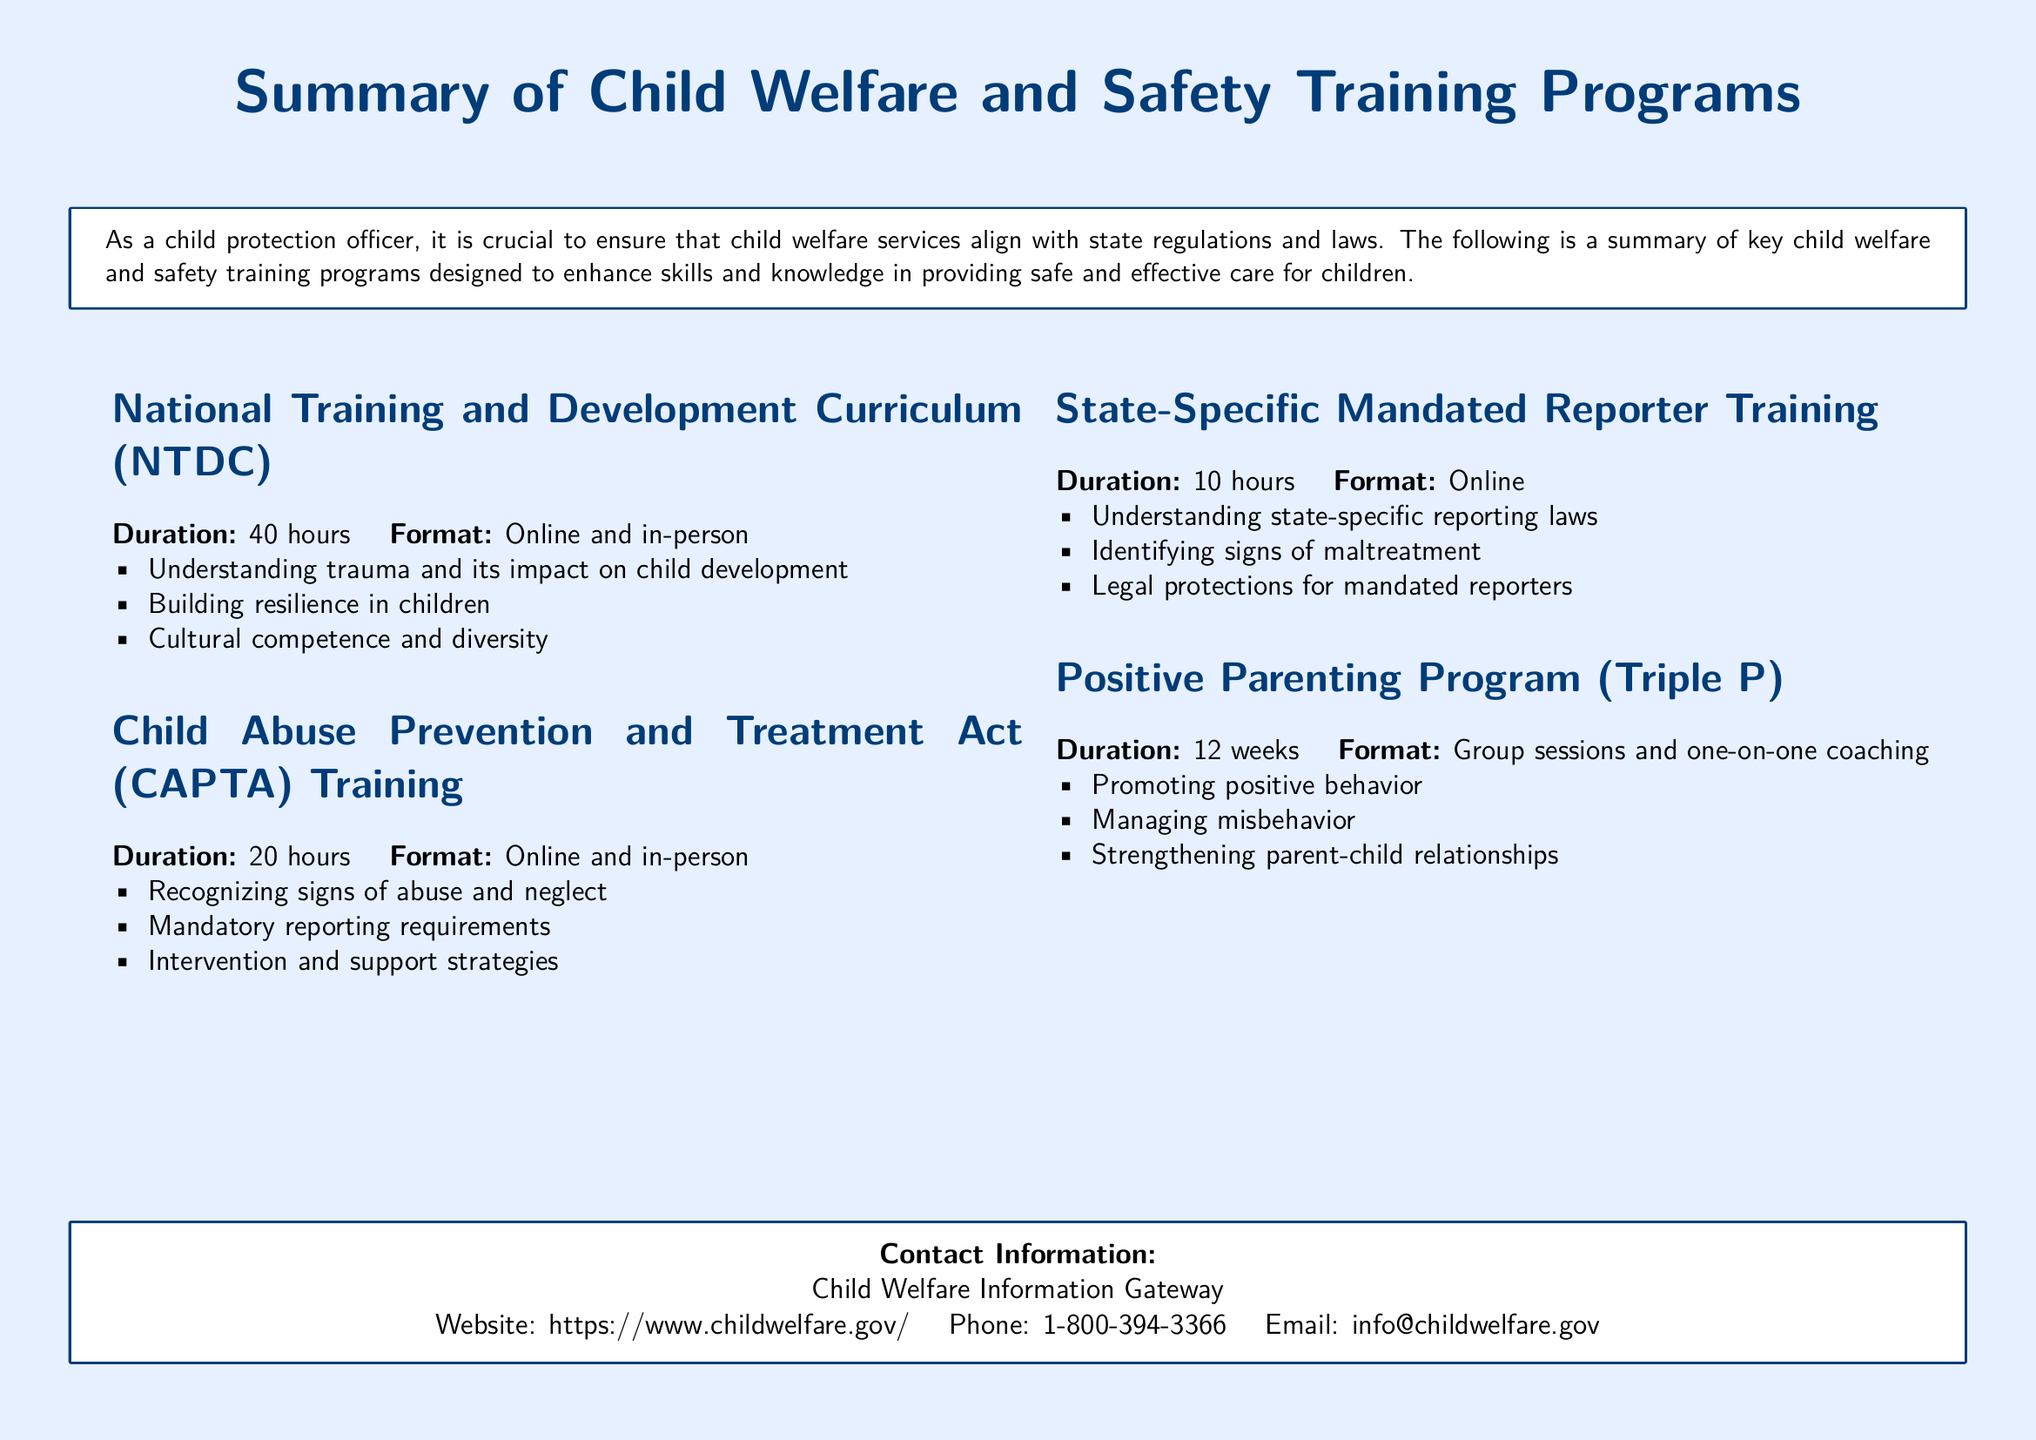What is the duration of the National Training and Development Curriculum? The duration is specifically mentioned in the document; it is 40 hours.
Answer: 40 hours What is one focus area of the Child Abuse Prevention and Treatment Act Training? The document lists focus areas for this training, one of which is recognizing signs of abuse and neglect.
Answer: Recognizing signs of abuse and neglect How many hours does the State-Specific Mandated Reporter Training last? The document states the training's duration as 10 hours.
Answer: 10 hours What is the format of the Positive Parenting Program? The document describes the format as group sessions and one-on-one coaching.
Answer: Group sessions and one-on-one coaching What is the total duration of the Positive Parenting Program? The total duration is noted in the document as 12 weeks.
Answer: 12 weeks What common goal do the training programs serve? These programs are designed to enhance skills and knowledge in providing safe and effective care for children, as stated in the document.
Answer: Safe and effective care for children What organization provides the contact information at the end of the document? The document lists the Child Welfare Information Gateway as the organization.
Answer: Child Welfare Information Gateway What is the website mentioned for contact information? The website provided in the document is https://www.childwelfare.gov/.
Answer: https://www.childwelfare.gov/ What is the main color used in the document's background? The document specifies that the page color is light blue.
Answer: Light blue What type of training format is common for CAPTA Training? The document mentions that the training format is online and in-person.
Answer: Online and in-person 